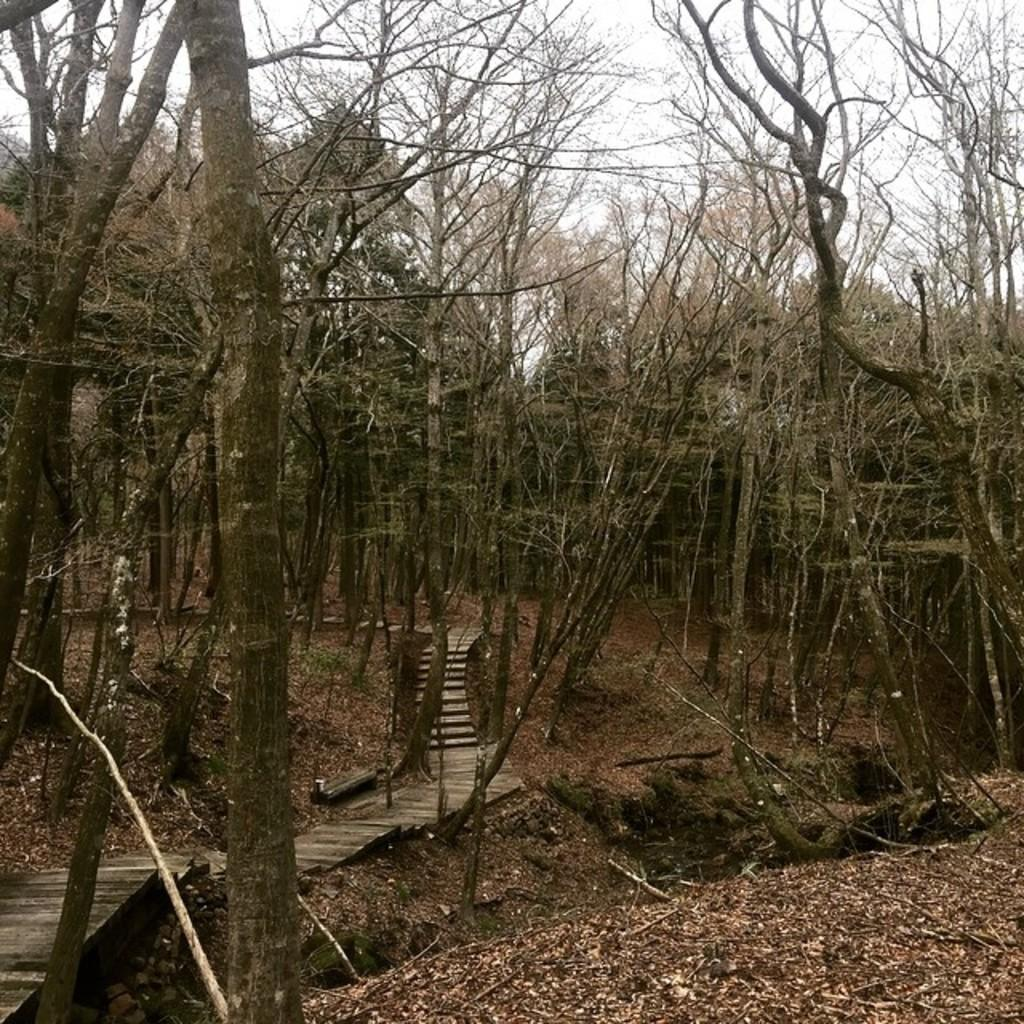What can be seen in the background of the image? The sky is visible in the image. What type of vegetation is present in the image? There are trees and leaves in the image. What is the surface that people might walk on in the image? There is a walkway in the image. Can you describe the pain that the duck is experiencing in the image? There is no duck present in the image, so it is not possible to describe any pain it might be experiencing. 